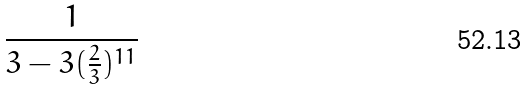<formula> <loc_0><loc_0><loc_500><loc_500>\frac { 1 } { 3 - 3 ( \frac { 2 } { 3 } ) ^ { 1 1 } }</formula> 